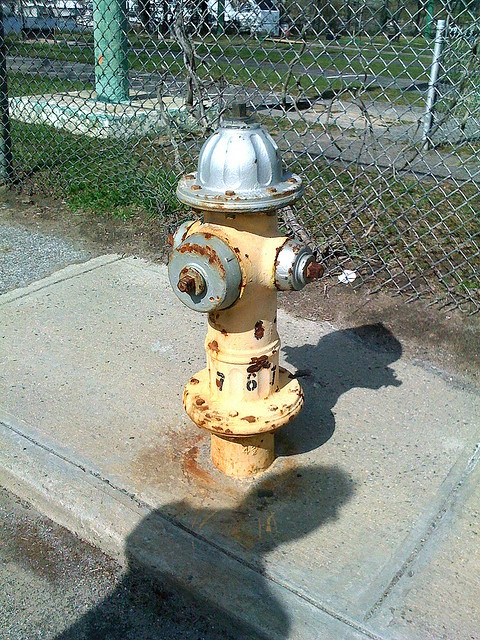Describe the objects in this image and their specific colors. I can see a fire hydrant in purple, khaki, ivory, darkgray, and olive tones in this image. 